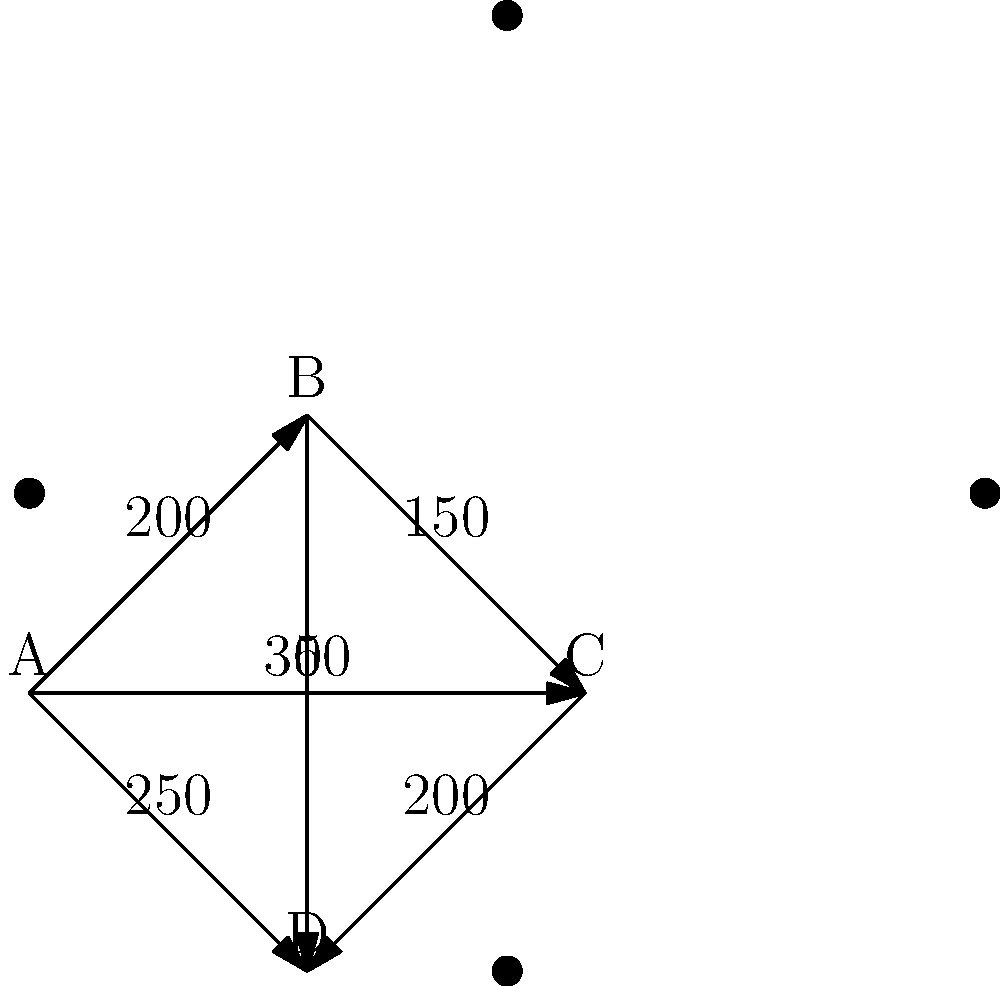As a commercial airline pilot, you're tasked with finding the most fuel-efficient route from Airport A to Airport D. The weighted graph represents distances between airports in nautical miles. What is the shortest total distance from A to D, and through which airports should the flight path go? To solve this problem, we'll use Dijkstra's algorithm to find the shortest path from A to D:

1. Initialize:
   - Distance to A: 0
   - Distance to B, C, D: Infinity
   - Previous node for all: Undefined

2. Visit A:
   - Update B: 200 (via A)
   - Update C: 350 (via A)
   - Update D: 250 (via A)

3. Visit B (closest unvisited):
   - Update C: min(350, 200+150) = 350 (no change)
   - Update D: min(250, 200+300) = 250 (no change)

4. Visit D (closest unvisited):
   - No updates needed, as D is our destination

5. Backtrack the shortest path:
   D <- A

The shortest path is directly from A to D, with a total distance of 250 nautical miles.
Answer: 250 nautical miles, path: A -> D 